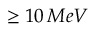<formula> <loc_0><loc_0><loc_500><loc_500>1 0 \, M e V</formula> 